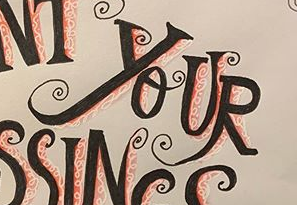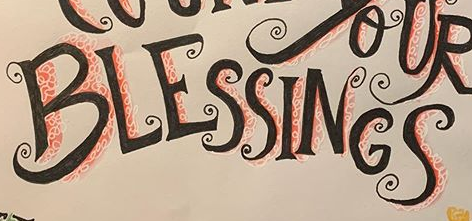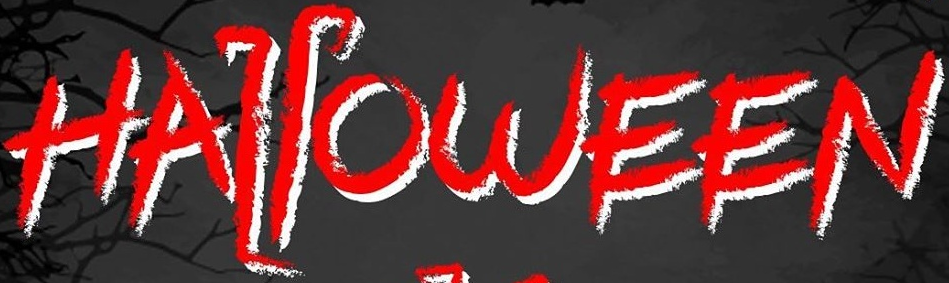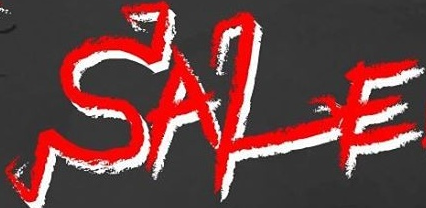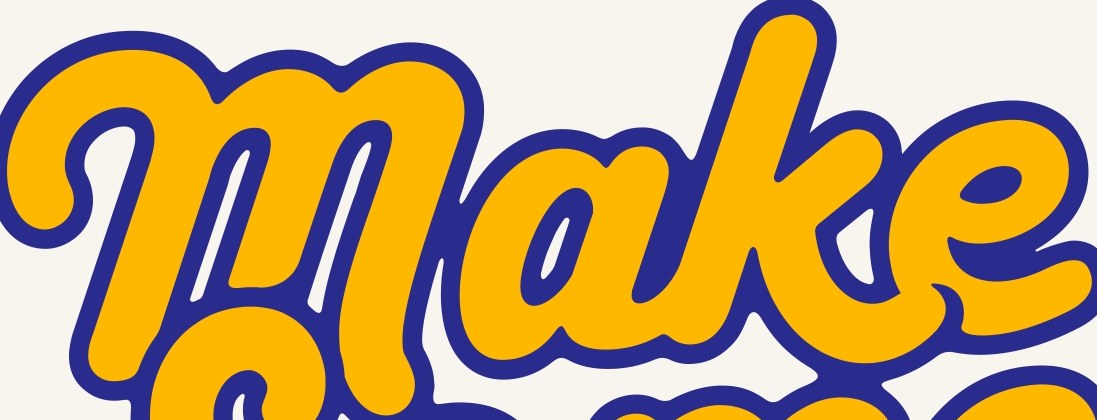What text appears in these images from left to right, separated by a semicolon? YOUR; BLESSINGS; HALLOWEEN; SALE; make 